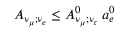<formula> <loc_0><loc_0><loc_500><loc_500>A _ { \nu _ { \mu } ; \nu _ { e } } \leq A _ { \nu _ { \mu } ; \nu _ { \tau } } ^ { 0 } \, a _ { e } ^ { 0 }</formula> 